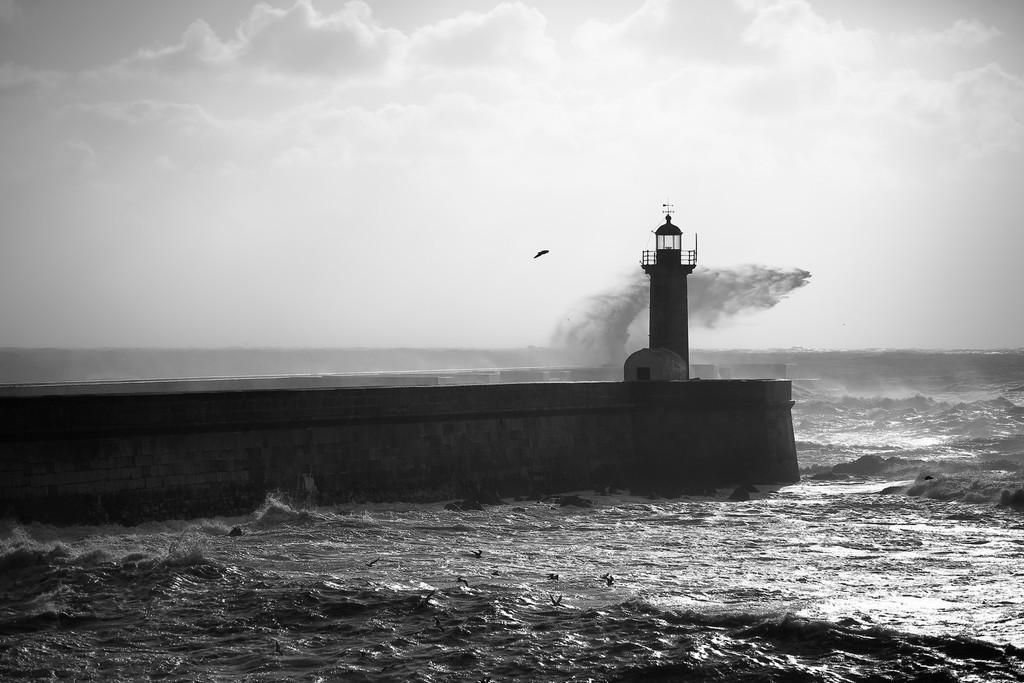Could you give a brief overview of what you see in this image? In this picture there is a bridge and there is a light house. At the top there are clouds. At the bottom there is water. 